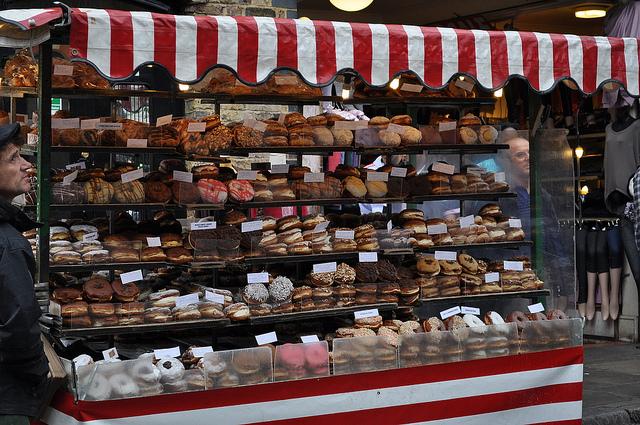Is this a bakery?
Be succinct. Yes. What color is the booth?
Be succinct. Red and white. Is the display case full?
Short answer required. Yes. 